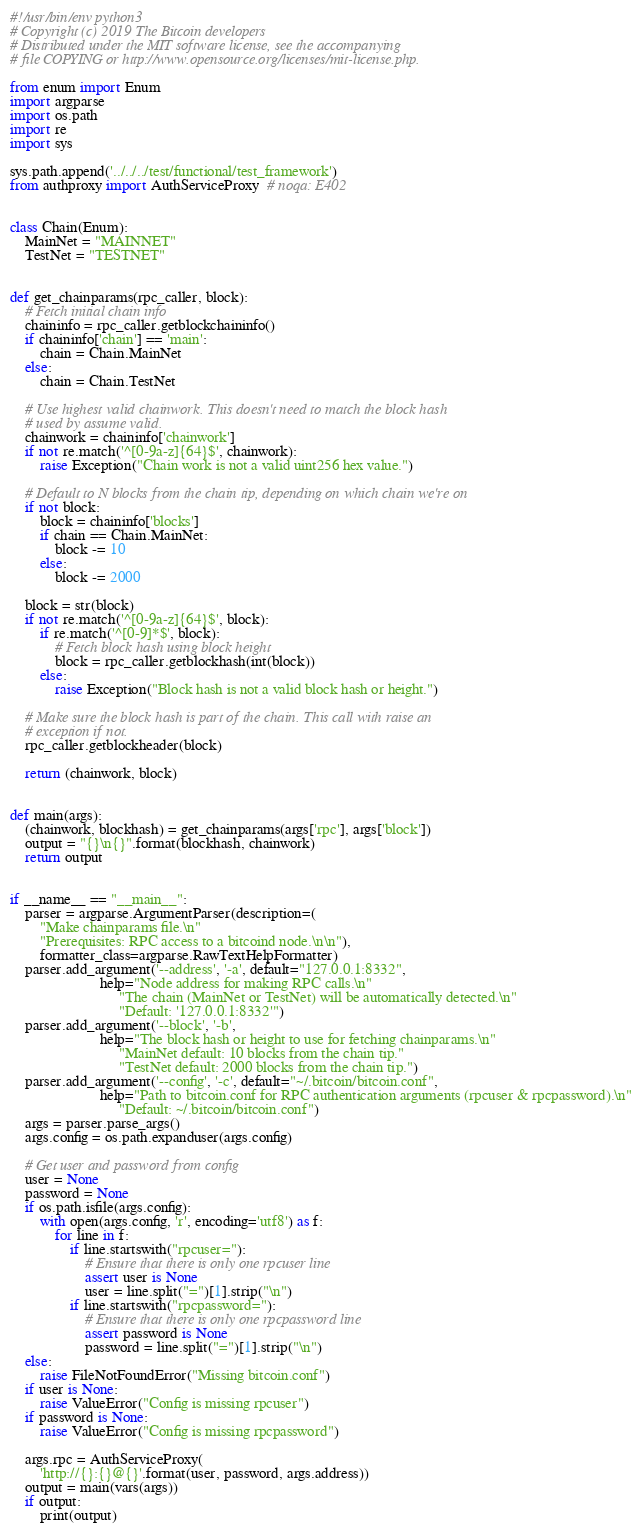<code> <loc_0><loc_0><loc_500><loc_500><_Python_>#!/usr/bin/env python3
# Copyright (c) 2019 The Bitcoin developers
# Distributed under the MIT software license, see the accompanying
# file COPYING or http://www.opensource.org/licenses/mit-license.php.

from enum import Enum
import argparse
import os.path
import re
import sys

sys.path.append('../../../test/functional/test_framework')
from authproxy import AuthServiceProxy  # noqa: E402


class Chain(Enum):
    MainNet = "MAINNET"
    TestNet = "TESTNET"


def get_chainparams(rpc_caller, block):
    # Fetch initial chain info
    chaininfo = rpc_caller.getblockchaininfo()
    if chaininfo['chain'] == 'main':
        chain = Chain.MainNet
    else:
        chain = Chain.TestNet

    # Use highest valid chainwork. This doesn't need to match the block hash
    # used by assume valid.
    chainwork = chaininfo['chainwork']
    if not re.match('^[0-9a-z]{64}$', chainwork):
        raise Exception("Chain work is not a valid uint256 hex value.")

    # Default to N blocks from the chain tip, depending on which chain we're on
    if not block:
        block = chaininfo['blocks']
        if chain == Chain.MainNet:
            block -= 10
        else:
            block -= 2000

    block = str(block)
    if not re.match('^[0-9a-z]{64}$', block):
        if re.match('^[0-9]*$', block):
            # Fetch block hash using block height
            block = rpc_caller.getblockhash(int(block))
        else:
            raise Exception("Block hash is not a valid block hash or height.")

    # Make sure the block hash is part of the chain. This call with raise an
    # exception if not.
    rpc_caller.getblockheader(block)

    return (chainwork, block)


def main(args):
    (chainwork, blockhash) = get_chainparams(args['rpc'], args['block'])
    output = "{}\n{}".format(blockhash, chainwork)
    return output


if __name__ == "__main__":
    parser = argparse.ArgumentParser(description=(
        "Make chainparams file.\n"
        "Prerequisites: RPC access to a bitcoind node.\n\n"),
        formatter_class=argparse.RawTextHelpFormatter)
    parser.add_argument('--address', '-a', default="127.0.0.1:8332",
                        help="Node address for making RPC calls.\n"
                             "The chain (MainNet or TestNet) will be automatically detected.\n"
                             "Default: '127.0.0.1:8332'")
    parser.add_argument('--block', '-b',
                        help="The block hash or height to use for fetching chainparams.\n"
                             "MainNet default: 10 blocks from the chain tip."
                             "TestNet default: 2000 blocks from the chain tip.")
    parser.add_argument('--config', '-c', default="~/.bitcoin/bitcoin.conf",
                        help="Path to bitcoin.conf for RPC authentication arguments (rpcuser & rpcpassword).\n"
                             "Default: ~/.bitcoin/bitcoin.conf")
    args = parser.parse_args()
    args.config = os.path.expanduser(args.config)

    # Get user and password from config
    user = None
    password = None
    if os.path.isfile(args.config):
        with open(args.config, 'r', encoding='utf8') as f:
            for line in f:
                if line.startswith("rpcuser="):
                    # Ensure that there is only one rpcuser line
                    assert user is None
                    user = line.split("=")[1].strip("\n")
                if line.startswith("rpcpassword="):
                    # Ensure that there is only one rpcpassword line
                    assert password is None
                    password = line.split("=")[1].strip("\n")
    else:
        raise FileNotFoundError("Missing bitcoin.conf")
    if user is None:
        raise ValueError("Config is missing rpcuser")
    if password is None:
        raise ValueError("Config is missing rpcpassword")

    args.rpc = AuthServiceProxy(
        'http://{}:{}@{}'.format(user, password, args.address))
    output = main(vars(args))
    if output:
        print(output)
</code> 